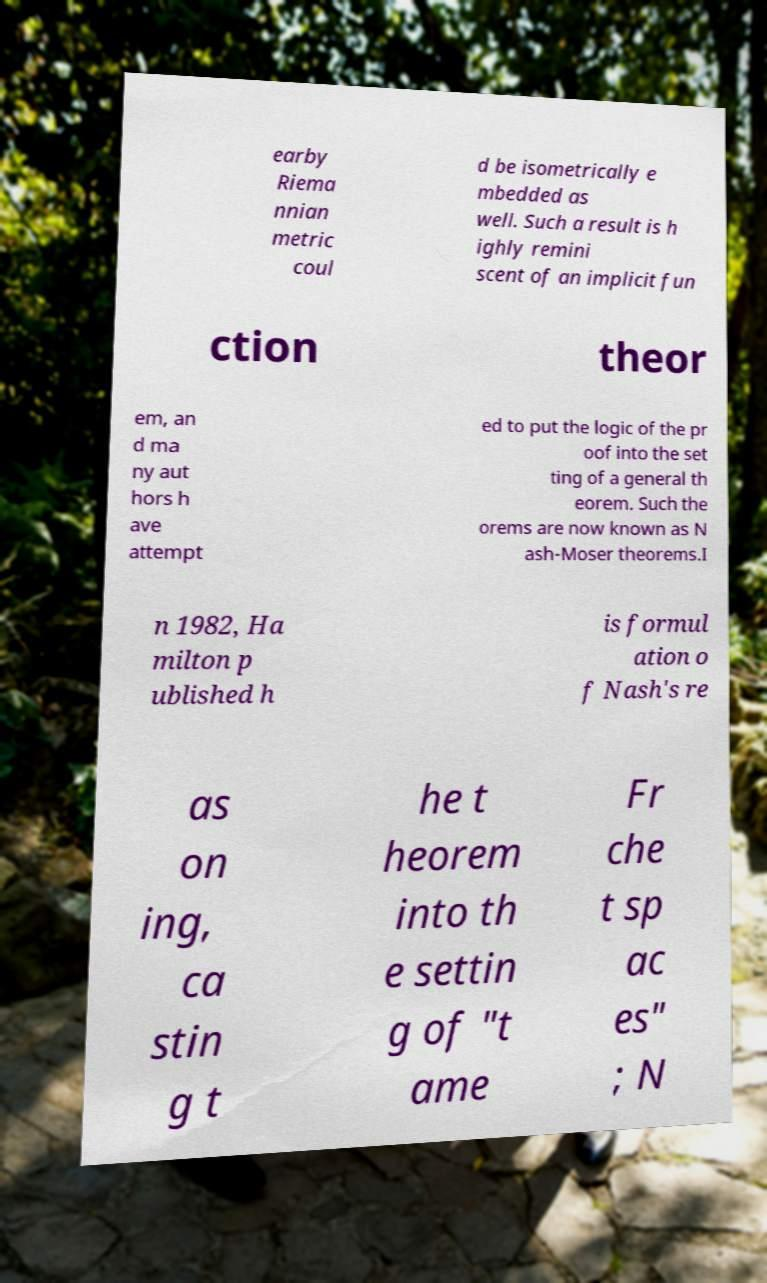Could you assist in decoding the text presented in this image and type it out clearly? earby Riema nnian metric coul d be isometrically e mbedded as well. Such a result is h ighly remini scent of an implicit fun ction theor em, an d ma ny aut hors h ave attempt ed to put the logic of the pr oof into the set ting of a general th eorem. Such the orems are now known as N ash-Moser theorems.I n 1982, Ha milton p ublished h is formul ation o f Nash's re as on ing, ca stin g t he t heorem into th e settin g of "t ame Fr che t sp ac es" ; N 